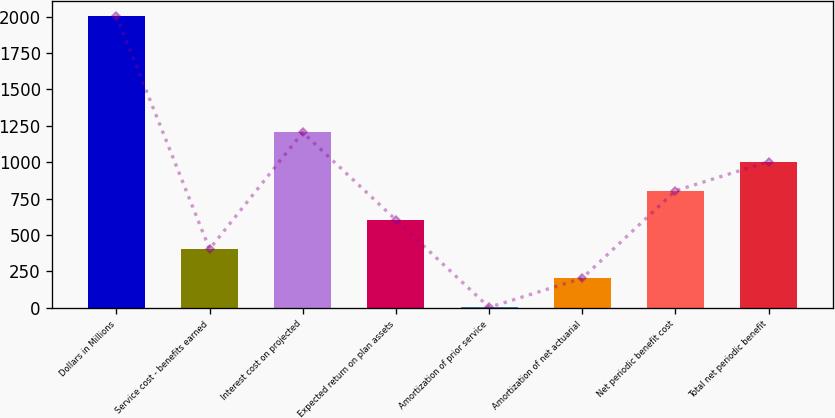Convert chart to OTSL. <chart><loc_0><loc_0><loc_500><loc_500><bar_chart><fcel>Dollars in Millions<fcel>Service cost - benefits earned<fcel>Interest cost on projected<fcel>Expected return on plan assets<fcel>Amortization of prior service<fcel>Amortization of net actuarial<fcel>Net periodic benefit cost<fcel>Total net periodic benefit<nl><fcel>2006<fcel>403.6<fcel>1204.8<fcel>603.9<fcel>3<fcel>203.3<fcel>804.2<fcel>1004.5<nl></chart> 